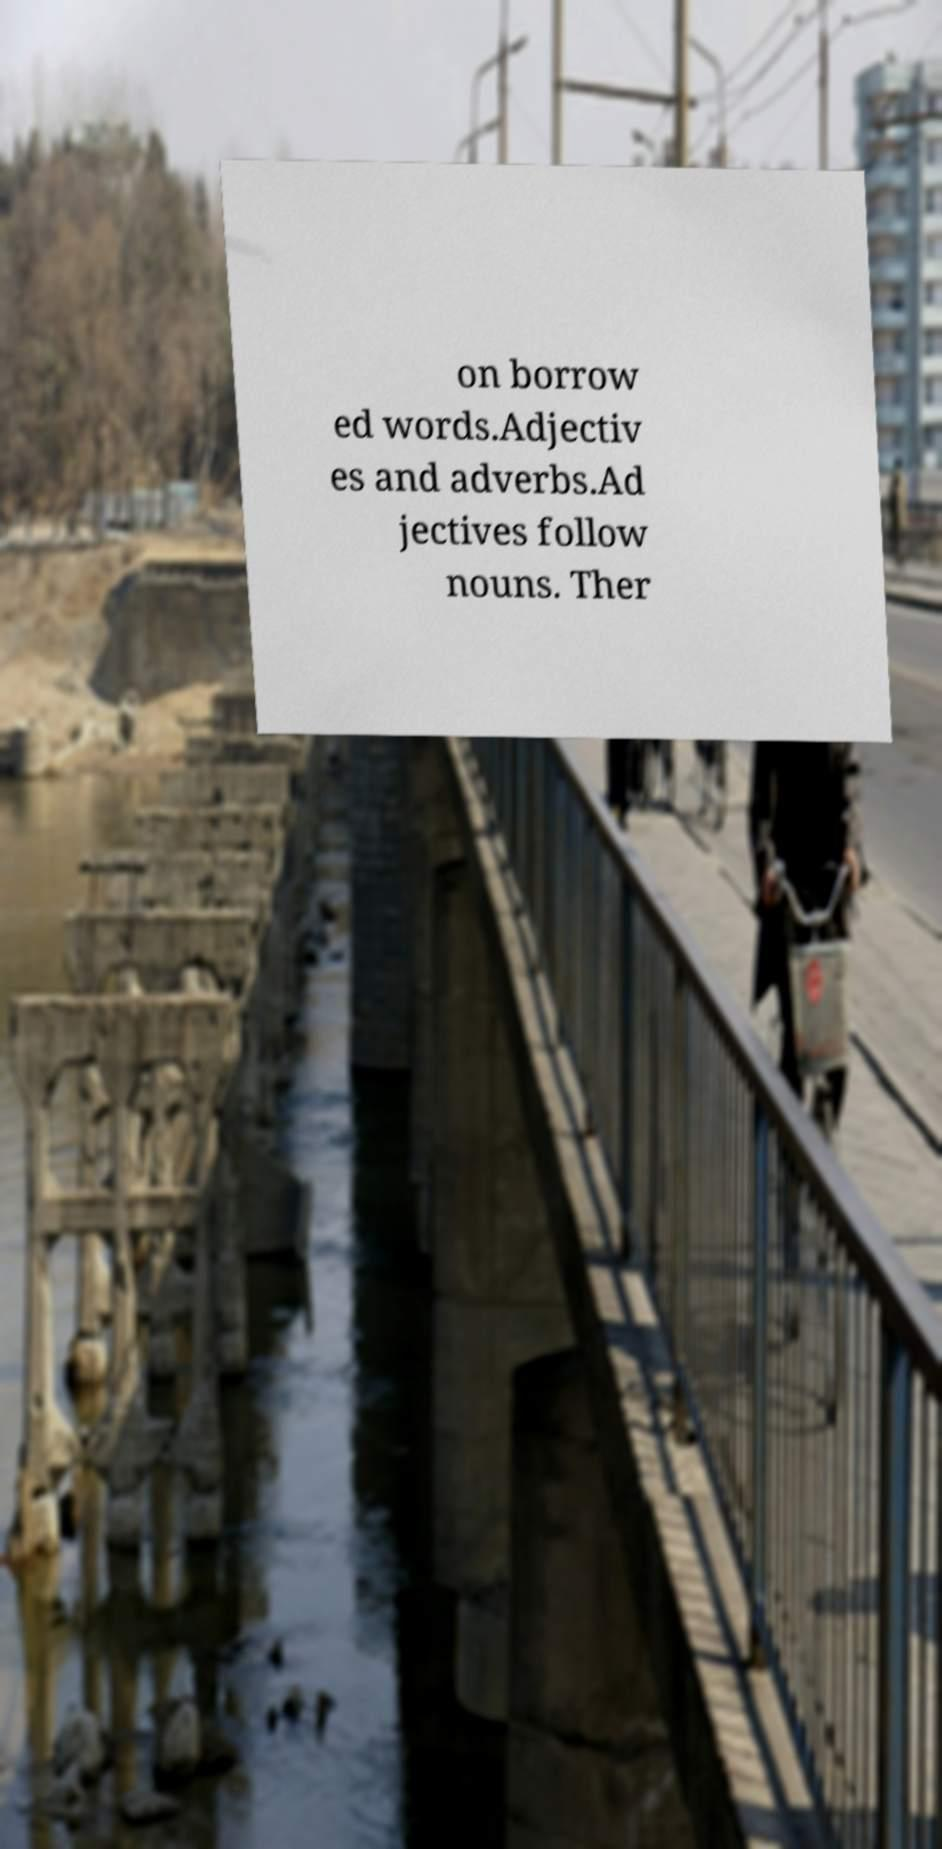I need the written content from this picture converted into text. Can you do that? on borrow ed words.Adjectiv es and adverbs.Ad jectives follow nouns. Ther 